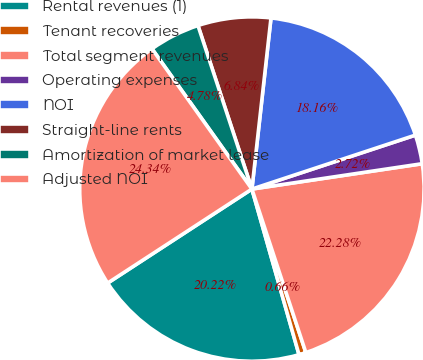<chart> <loc_0><loc_0><loc_500><loc_500><pie_chart><fcel>Rental revenues (1)<fcel>Tenant recoveries<fcel>Total segment revenues<fcel>Operating expenses<fcel>NOI<fcel>Straight-line rents<fcel>Amortization of market lease<fcel>Adjusted NOI<nl><fcel>20.22%<fcel>0.66%<fcel>22.28%<fcel>2.72%<fcel>18.16%<fcel>6.84%<fcel>4.78%<fcel>24.34%<nl></chart> 